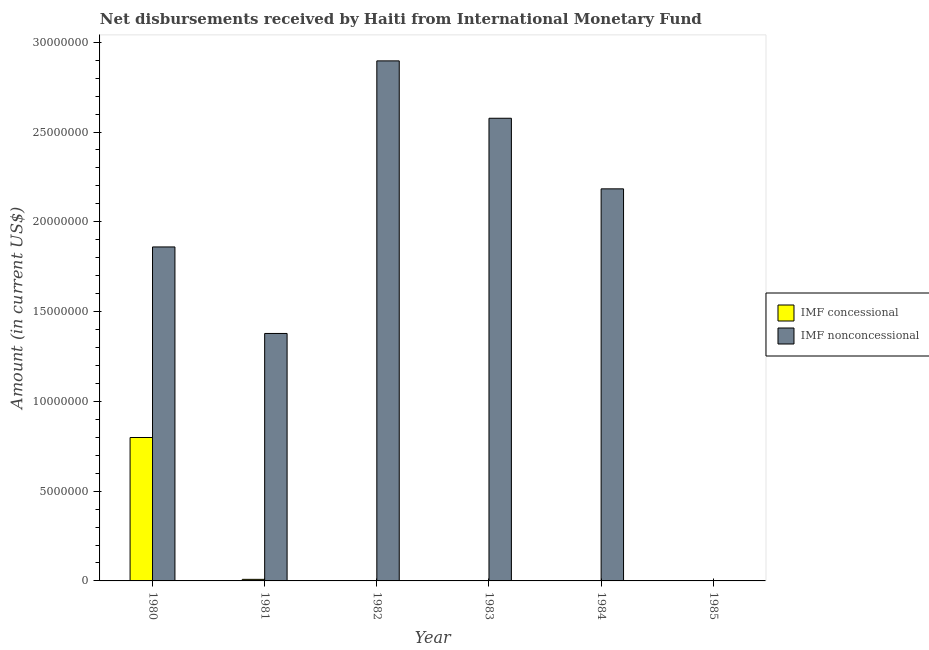How many different coloured bars are there?
Ensure brevity in your answer.  2. In how many cases, is the number of bars for a given year not equal to the number of legend labels?
Provide a succinct answer. 4. What is the net non concessional disbursements from imf in 1980?
Make the answer very short. 1.86e+07. Across all years, what is the maximum net concessional disbursements from imf?
Offer a terse response. 7.99e+06. In which year was the net non concessional disbursements from imf maximum?
Offer a very short reply. 1982. What is the total net non concessional disbursements from imf in the graph?
Provide a short and direct response. 1.09e+08. What is the difference between the net non concessional disbursements from imf in 1982 and that in 1984?
Provide a succinct answer. 7.13e+06. What is the difference between the net non concessional disbursements from imf in 1981 and the net concessional disbursements from imf in 1982?
Your answer should be compact. -1.52e+07. What is the average net concessional disbursements from imf per year?
Your answer should be very brief. 1.35e+06. In the year 1983, what is the difference between the net non concessional disbursements from imf and net concessional disbursements from imf?
Your answer should be very brief. 0. What is the ratio of the net non concessional disbursements from imf in 1983 to that in 1984?
Provide a short and direct response. 1.18. Is the net non concessional disbursements from imf in 1980 less than that in 1981?
Offer a terse response. No. What is the difference between the highest and the second highest net non concessional disbursements from imf?
Make the answer very short. 3.20e+06. What is the difference between the highest and the lowest net concessional disbursements from imf?
Provide a succinct answer. 7.99e+06. How many bars are there?
Give a very brief answer. 7. What is the difference between two consecutive major ticks on the Y-axis?
Your response must be concise. 5.00e+06. Where does the legend appear in the graph?
Ensure brevity in your answer.  Center right. How many legend labels are there?
Your response must be concise. 2. What is the title of the graph?
Your answer should be very brief. Net disbursements received by Haiti from International Monetary Fund. Does "Stunting" appear as one of the legend labels in the graph?
Provide a succinct answer. No. What is the label or title of the X-axis?
Your answer should be very brief. Year. What is the Amount (in current US$) of IMF concessional in 1980?
Make the answer very short. 7.99e+06. What is the Amount (in current US$) in IMF nonconcessional in 1980?
Give a very brief answer. 1.86e+07. What is the Amount (in current US$) of IMF concessional in 1981?
Give a very brief answer. 8.70e+04. What is the Amount (in current US$) in IMF nonconcessional in 1981?
Provide a short and direct response. 1.38e+07. What is the Amount (in current US$) of IMF concessional in 1982?
Provide a short and direct response. 0. What is the Amount (in current US$) of IMF nonconcessional in 1982?
Offer a very short reply. 2.90e+07. What is the Amount (in current US$) of IMF concessional in 1983?
Provide a succinct answer. 0. What is the Amount (in current US$) of IMF nonconcessional in 1983?
Offer a very short reply. 2.58e+07. What is the Amount (in current US$) of IMF nonconcessional in 1984?
Keep it short and to the point. 2.18e+07. Across all years, what is the maximum Amount (in current US$) of IMF concessional?
Your answer should be compact. 7.99e+06. Across all years, what is the maximum Amount (in current US$) of IMF nonconcessional?
Your answer should be very brief. 2.90e+07. Across all years, what is the minimum Amount (in current US$) of IMF nonconcessional?
Keep it short and to the point. 0. What is the total Amount (in current US$) of IMF concessional in the graph?
Ensure brevity in your answer.  8.07e+06. What is the total Amount (in current US$) of IMF nonconcessional in the graph?
Offer a very short reply. 1.09e+08. What is the difference between the Amount (in current US$) of IMF concessional in 1980 and that in 1981?
Your answer should be compact. 7.90e+06. What is the difference between the Amount (in current US$) in IMF nonconcessional in 1980 and that in 1981?
Provide a short and direct response. 4.82e+06. What is the difference between the Amount (in current US$) of IMF nonconcessional in 1980 and that in 1982?
Keep it short and to the point. -1.04e+07. What is the difference between the Amount (in current US$) of IMF nonconcessional in 1980 and that in 1983?
Provide a short and direct response. -7.17e+06. What is the difference between the Amount (in current US$) in IMF nonconcessional in 1980 and that in 1984?
Provide a short and direct response. -3.24e+06. What is the difference between the Amount (in current US$) of IMF nonconcessional in 1981 and that in 1982?
Provide a succinct answer. -1.52e+07. What is the difference between the Amount (in current US$) of IMF nonconcessional in 1981 and that in 1983?
Keep it short and to the point. -1.20e+07. What is the difference between the Amount (in current US$) in IMF nonconcessional in 1981 and that in 1984?
Provide a short and direct response. -8.05e+06. What is the difference between the Amount (in current US$) of IMF nonconcessional in 1982 and that in 1983?
Provide a succinct answer. 3.20e+06. What is the difference between the Amount (in current US$) of IMF nonconcessional in 1982 and that in 1984?
Make the answer very short. 7.13e+06. What is the difference between the Amount (in current US$) of IMF nonconcessional in 1983 and that in 1984?
Keep it short and to the point. 3.93e+06. What is the difference between the Amount (in current US$) in IMF concessional in 1980 and the Amount (in current US$) in IMF nonconcessional in 1981?
Your answer should be very brief. -5.79e+06. What is the difference between the Amount (in current US$) in IMF concessional in 1980 and the Amount (in current US$) in IMF nonconcessional in 1982?
Your answer should be compact. -2.10e+07. What is the difference between the Amount (in current US$) of IMF concessional in 1980 and the Amount (in current US$) of IMF nonconcessional in 1983?
Make the answer very short. -1.78e+07. What is the difference between the Amount (in current US$) of IMF concessional in 1980 and the Amount (in current US$) of IMF nonconcessional in 1984?
Ensure brevity in your answer.  -1.38e+07. What is the difference between the Amount (in current US$) in IMF concessional in 1981 and the Amount (in current US$) in IMF nonconcessional in 1982?
Offer a terse response. -2.89e+07. What is the difference between the Amount (in current US$) of IMF concessional in 1981 and the Amount (in current US$) of IMF nonconcessional in 1983?
Your response must be concise. -2.57e+07. What is the difference between the Amount (in current US$) in IMF concessional in 1981 and the Amount (in current US$) in IMF nonconcessional in 1984?
Keep it short and to the point. -2.17e+07. What is the average Amount (in current US$) in IMF concessional per year?
Your answer should be very brief. 1.35e+06. What is the average Amount (in current US$) of IMF nonconcessional per year?
Give a very brief answer. 1.82e+07. In the year 1980, what is the difference between the Amount (in current US$) in IMF concessional and Amount (in current US$) in IMF nonconcessional?
Your answer should be very brief. -1.06e+07. In the year 1981, what is the difference between the Amount (in current US$) in IMF concessional and Amount (in current US$) in IMF nonconcessional?
Your answer should be very brief. -1.37e+07. What is the ratio of the Amount (in current US$) in IMF concessional in 1980 to that in 1981?
Your response must be concise. 91.8. What is the ratio of the Amount (in current US$) in IMF nonconcessional in 1980 to that in 1981?
Provide a succinct answer. 1.35. What is the ratio of the Amount (in current US$) in IMF nonconcessional in 1980 to that in 1982?
Your response must be concise. 0.64. What is the ratio of the Amount (in current US$) of IMF nonconcessional in 1980 to that in 1983?
Your answer should be compact. 0.72. What is the ratio of the Amount (in current US$) of IMF nonconcessional in 1980 to that in 1984?
Offer a terse response. 0.85. What is the ratio of the Amount (in current US$) of IMF nonconcessional in 1981 to that in 1982?
Give a very brief answer. 0.48. What is the ratio of the Amount (in current US$) of IMF nonconcessional in 1981 to that in 1983?
Ensure brevity in your answer.  0.53. What is the ratio of the Amount (in current US$) in IMF nonconcessional in 1981 to that in 1984?
Your response must be concise. 0.63. What is the ratio of the Amount (in current US$) in IMF nonconcessional in 1982 to that in 1983?
Offer a very short reply. 1.12. What is the ratio of the Amount (in current US$) in IMF nonconcessional in 1982 to that in 1984?
Provide a succinct answer. 1.33. What is the ratio of the Amount (in current US$) in IMF nonconcessional in 1983 to that in 1984?
Keep it short and to the point. 1.18. What is the difference between the highest and the second highest Amount (in current US$) in IMF nonconcessional?
Your response must be concise. 3.20e+06. What is the difference between the highest and the lowest Amount (in current US$) of IMF concessional?
Ensure brevity in your answer.  7.99e+06. What is the difference between the highest and the lowest Amount (in current US$) of IMF nonconcessional?
Make the answer very short. 2.90e+07. 